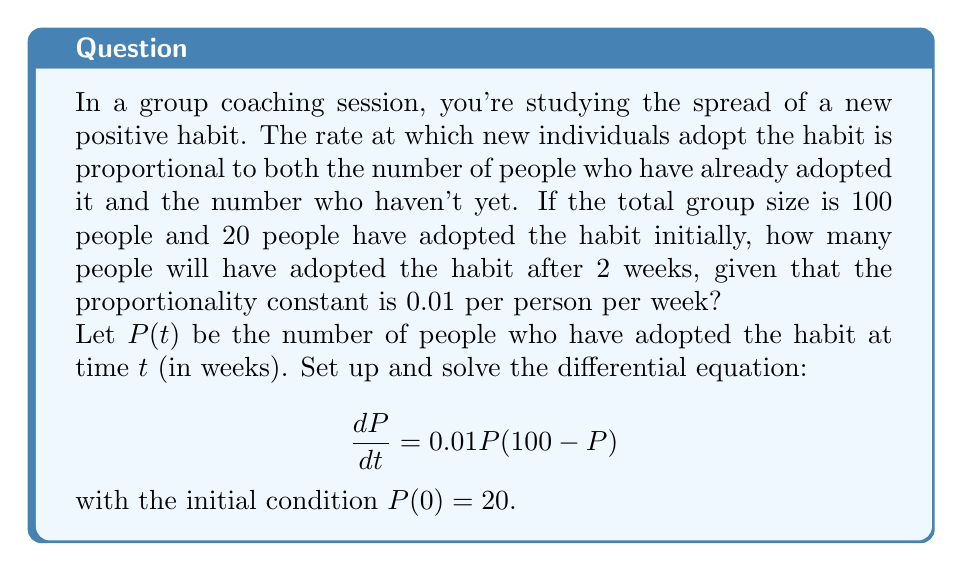Help me with this question. To solve this problem, we need to use the logistic differential equation, which models population growth with limiting factors.

1) The given differential equation is:
   $$\frac{dP}{dt} = 0.01P(100-P)$$

2) This is a separable equation. We can rewrite it as:
   $$\frac{dP}{P(100-P)} = 0.01dt$$

3) Integrate both sides:
   $$\int \frac{dP}{P(100-P)} = \int 0.01dt$$

4) The left side can be integrated using partial fractions:
   $$\frac{1}{100}\ln|\frac{P}{100-P}| = 0.01t + C$$

5) Solve for P:
   $$\frac{P}{100-P} = Ae^{t}$$
   where $A = e^{100C}$ and we've absorbed the 0.01 into $t$ for simplicity.

6) Simplify:
   $$P = \frac{100Ae^{t}}{1+Ae^{t}}$$

7) Use the initial condition $P(0) = 20$ to find A:
   $$20 = \frac{100A}{1+A}$$
   $$A = \frac{1}{4}$$

8) Therefore, the solution is:
   $$P(t) = \frac{100(0.25)e^{t}}{1+(0.25)e^{t}} = \frac{25e^{t}}{1+0.25e^{t}}$$

9) To find P(2), we substitute t = 2:
   $$P(2) = \frac{25e^{2}}{1+0.25e^{2}} \approx 45.76$$
Answer: After 2 weeks, approximately 46 people will have adopted the habit. 